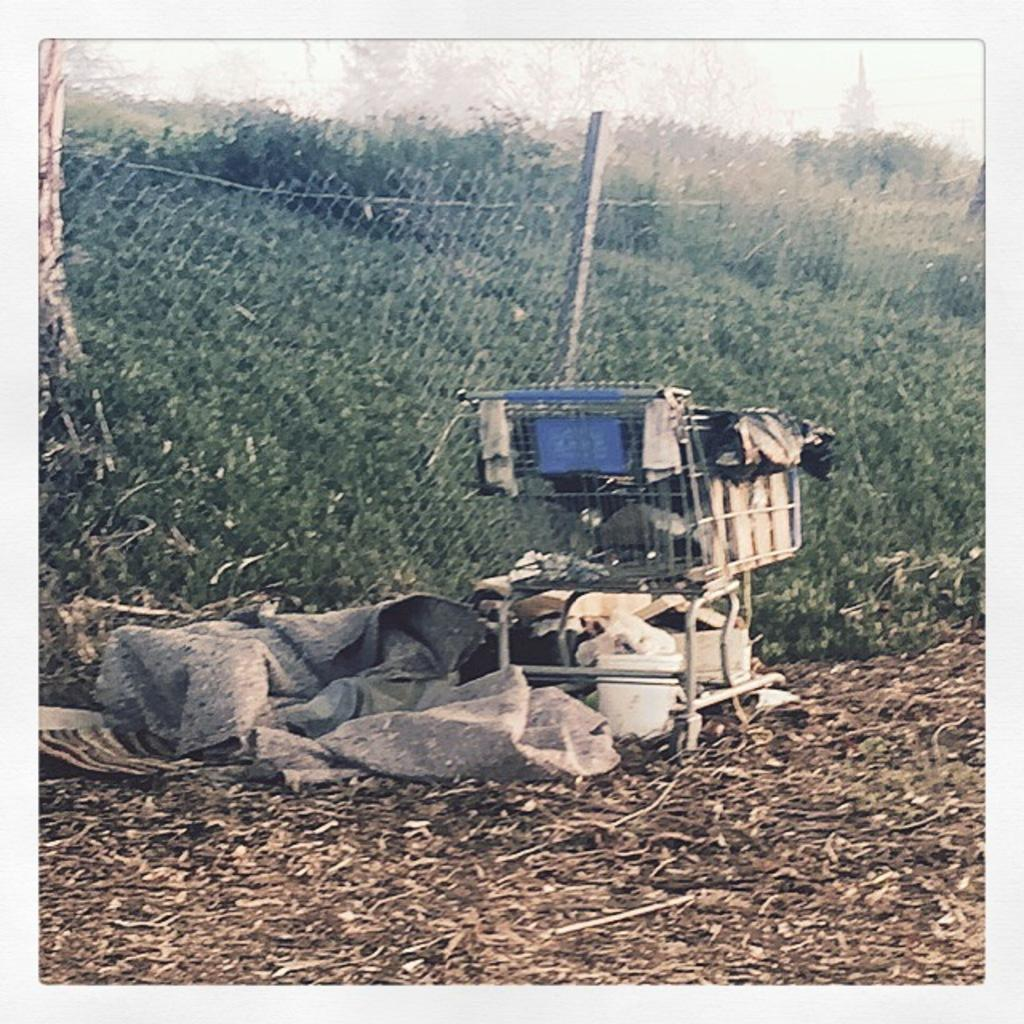What is the main object in the image? There is a trolley in the image. What color is the bucket that is visible in the image? The bucket in the image is white. What can be seen on the ground in the image? There are objects on the ground in the image. What is present in the background of the image? There is a net fence and many trees in the background of the image. What else can be seen in the background of the image? The sky is visible in the background of the image. How does the trolley attract the attention of the eyes in the image? The trolley does not attract the attention of the eyes in the image; it is just one of the objects present. What type of soda is being served in the image? There is no soda present in the image. 